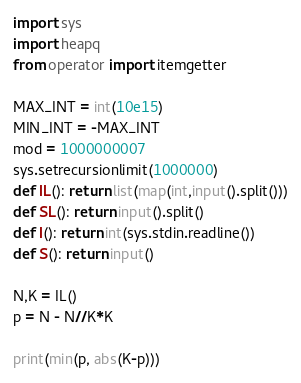<code> <loc_0><loc_0><loc_500><loc_500><_Python_>import sys
import heapq
from operator import itemgetter
 
MAX_INT = int(10e15)
MIN_INT = -MAX_INT
mod = 1000000007
sys.setrecursionlimit(1000000)
def IL(): return list(map(int,input().split()))
def SL(): return input().split()
def I(): return int(sys.stdin.readline())
def S(): return input()

N,K = IL()
p = N - N//K*K

print(min(p, abs(K-p)))</code> 